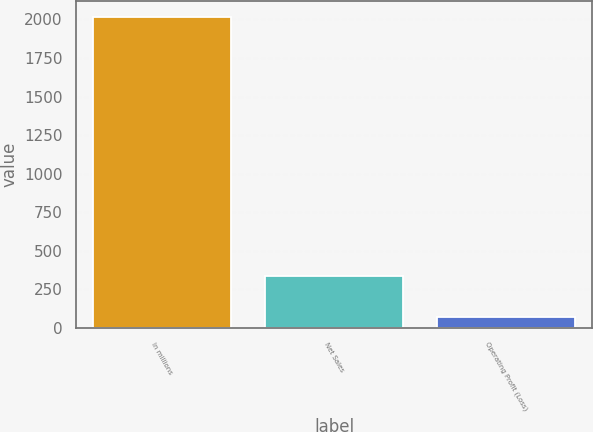<chart> <loc_0><loc_0><loc_500><loc_500><bar_chart><fcel>In millions<fcel>Net Sales<fcel>Operating Profit (Loss)<nl><fcel>2017<fcel>335<fcel>72<nl></chart> 